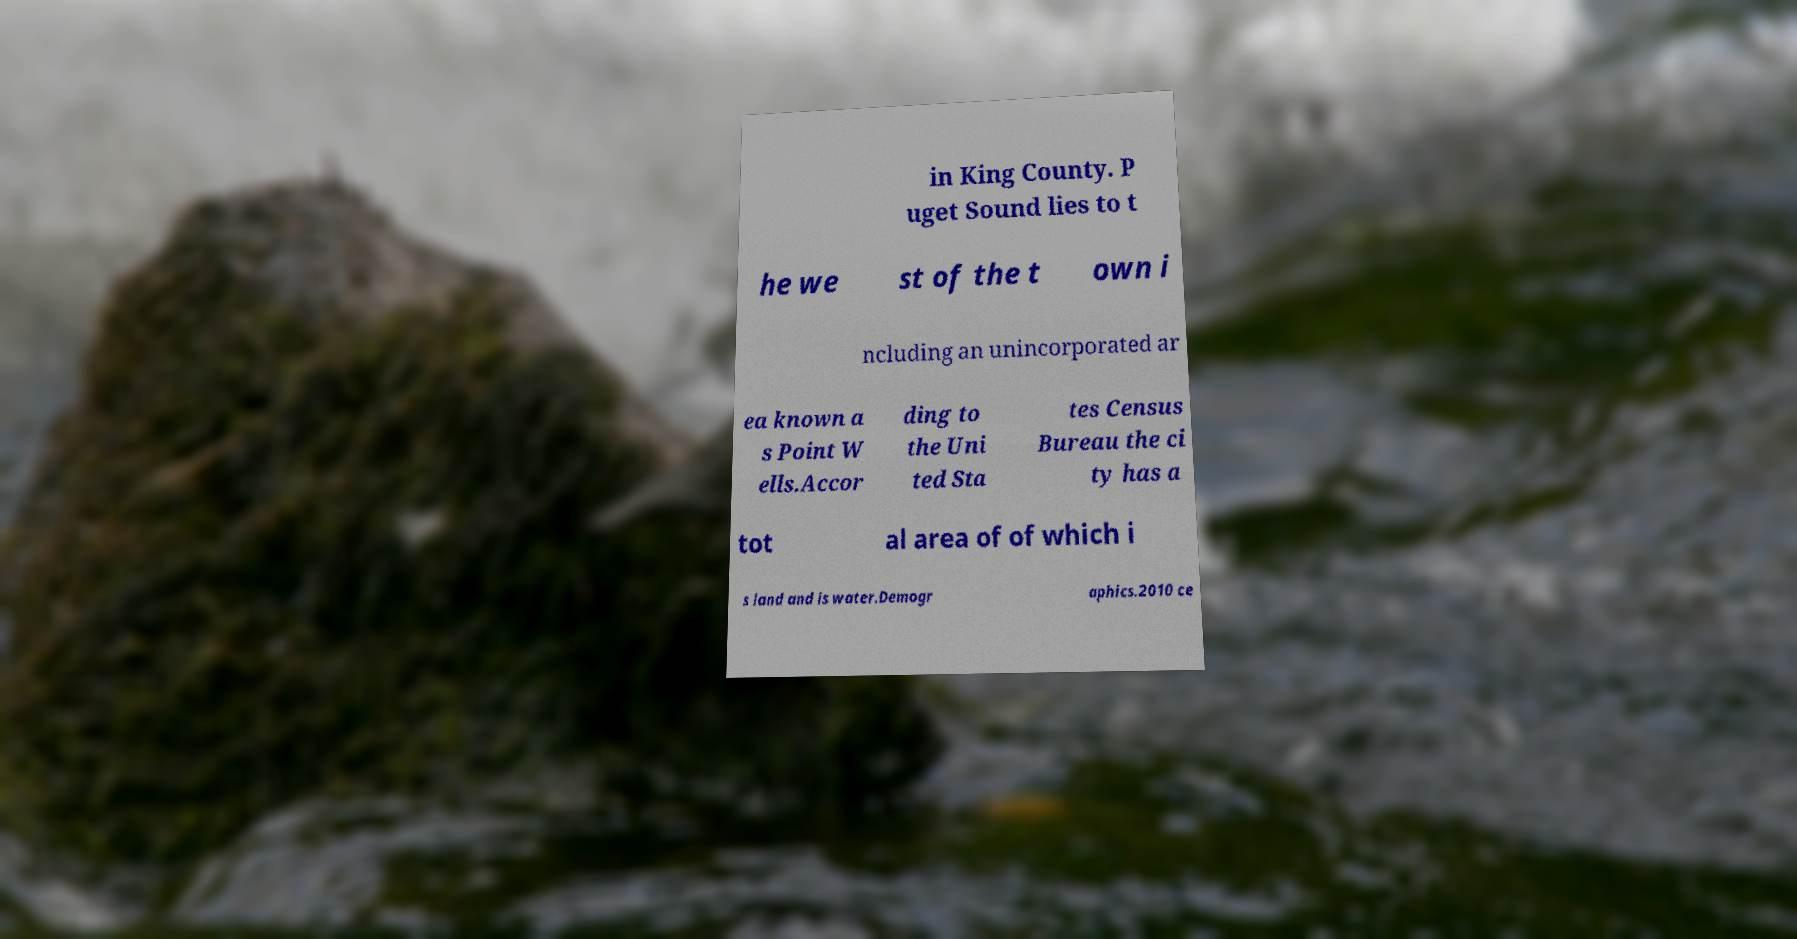Please identify and transcribe the text found in this image. in King County. P uget Sound lies to t he we st of the t own i ncluding an unincorporated ar ea known a s Point W ells.Accor ding to the Uni ted Sta tes Census Bureau the ci ty has a tot al area of of which i s land and is water.Demogr aphics.2010 ce 